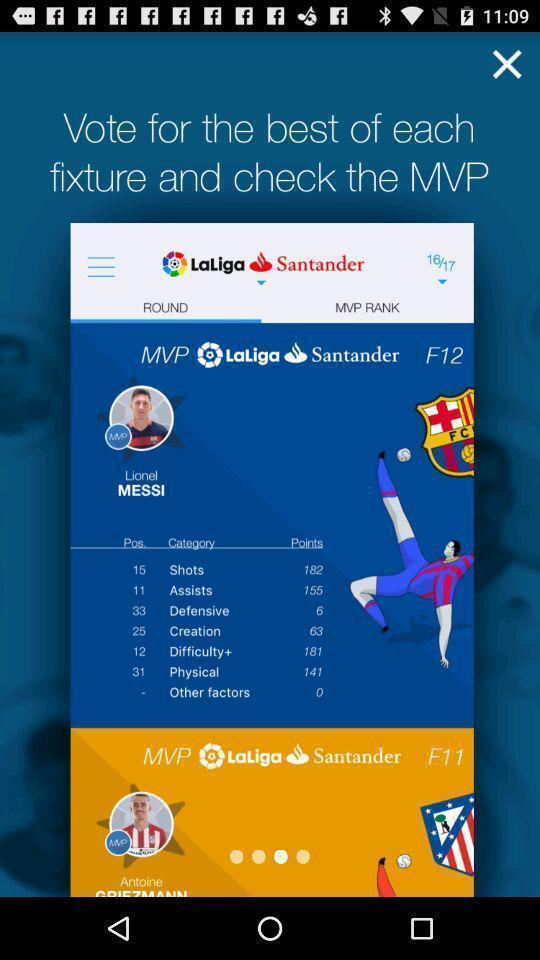Tell me about the visual elements in this screen capture. Screen showing vote for the best. 